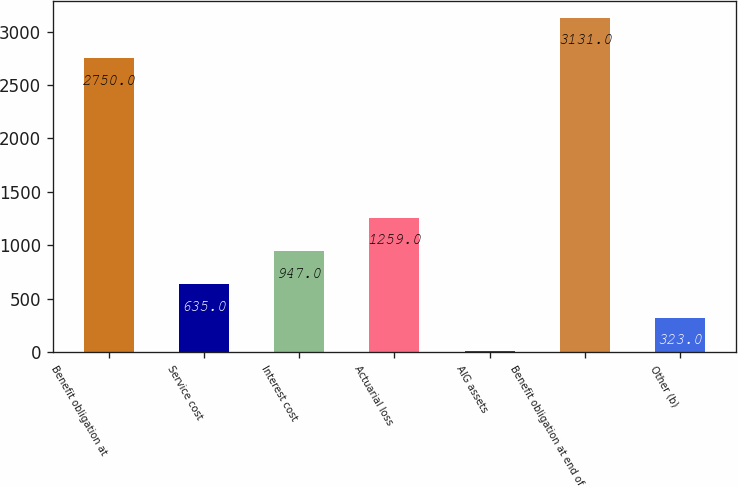<chart> <loc_0><loc_0><loc_500><loc_500><bar_chart><fcel>Benefit obligation at<fcel>Service cost<fcel>Interest cost<fcel>Actuarial loss<fcel>AIG assets<fcel>Benefit obligation at end of<fcel>Other (b)<nl><fcel>2750<fcel>635<fcel>947<fcel>1259<fcel>11<fcel>3131<fcel>323<nl></chart> 